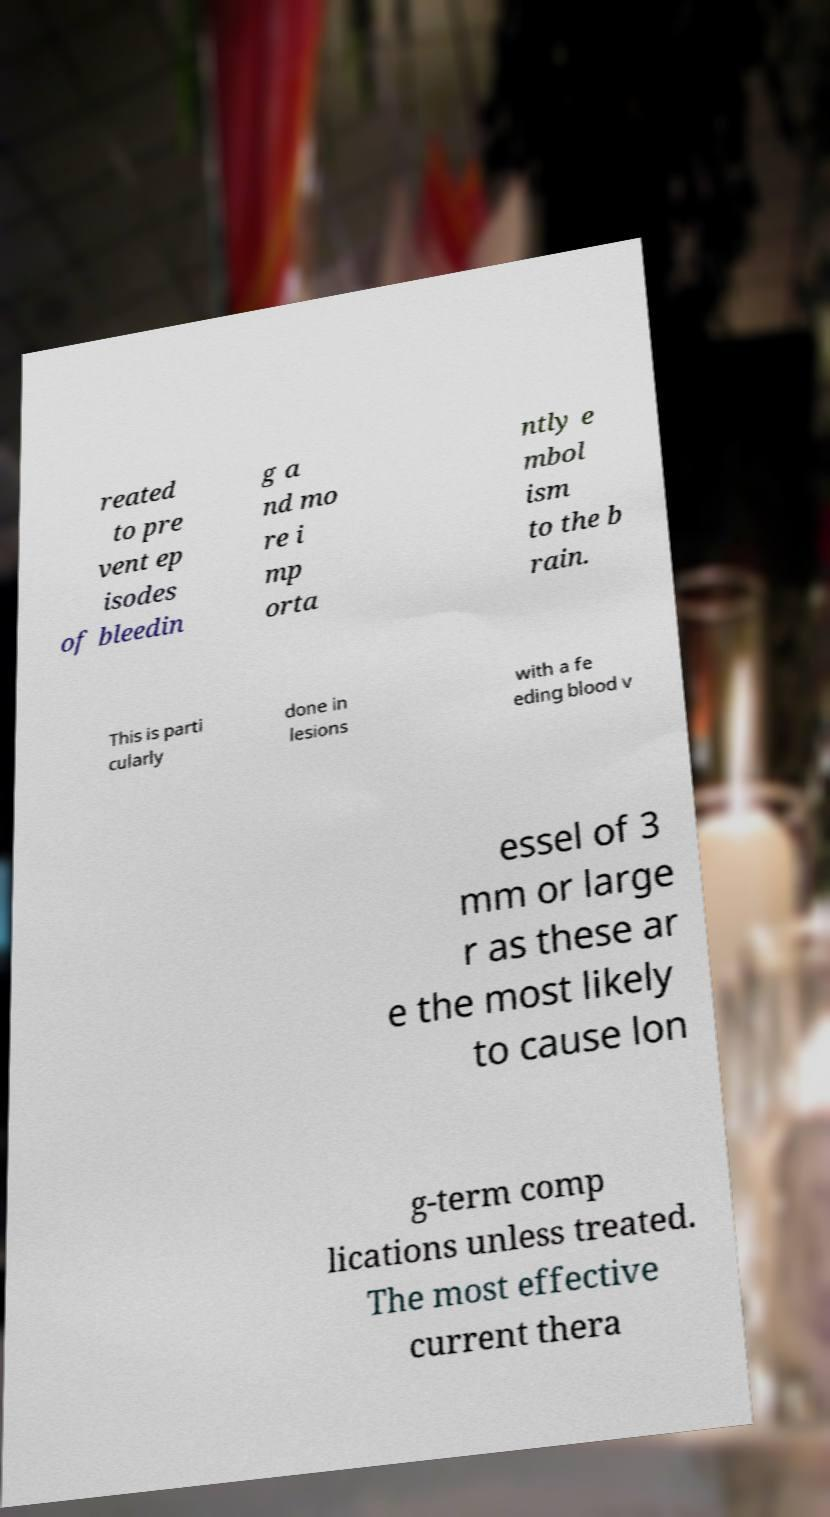What messages or text are displayed in this image? I need them in a readable, typed format. reated to pre vent ep isodes of bleedin g a nd mo re i mp orta ntly e mbol ism to the b rain. This is parti cularly done in lesions with a fe eding blood v essel of 3 mm or large r as these ar e the most likely to cause lon g-term comp lications unless treated. The most effective current thera 